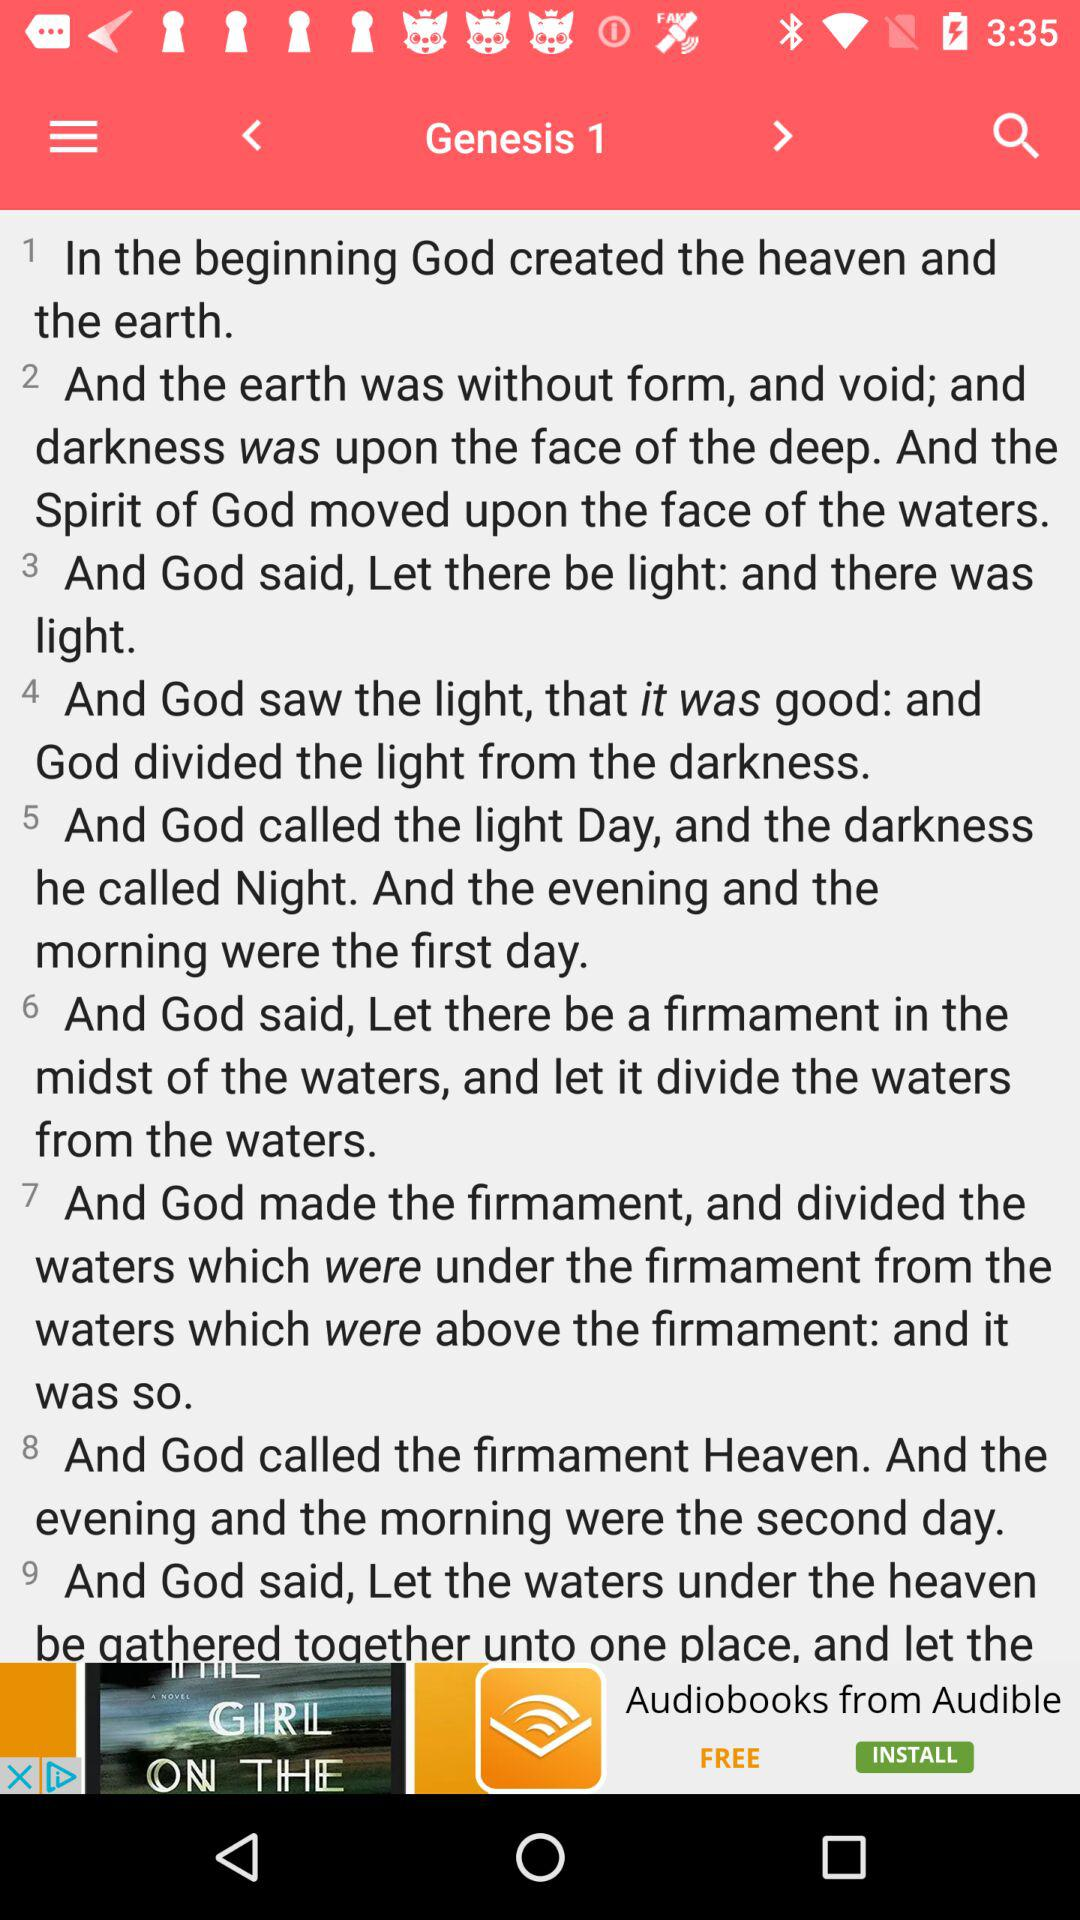What did God call the light? God calls the light "Day". 